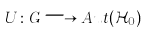Convert formula to latex. <formula><loc_0><loc_0><loc_500><loc_500>U \colon G \longrightarrow A u t ( \mathcal { H } _ { 0 } )</formula> 